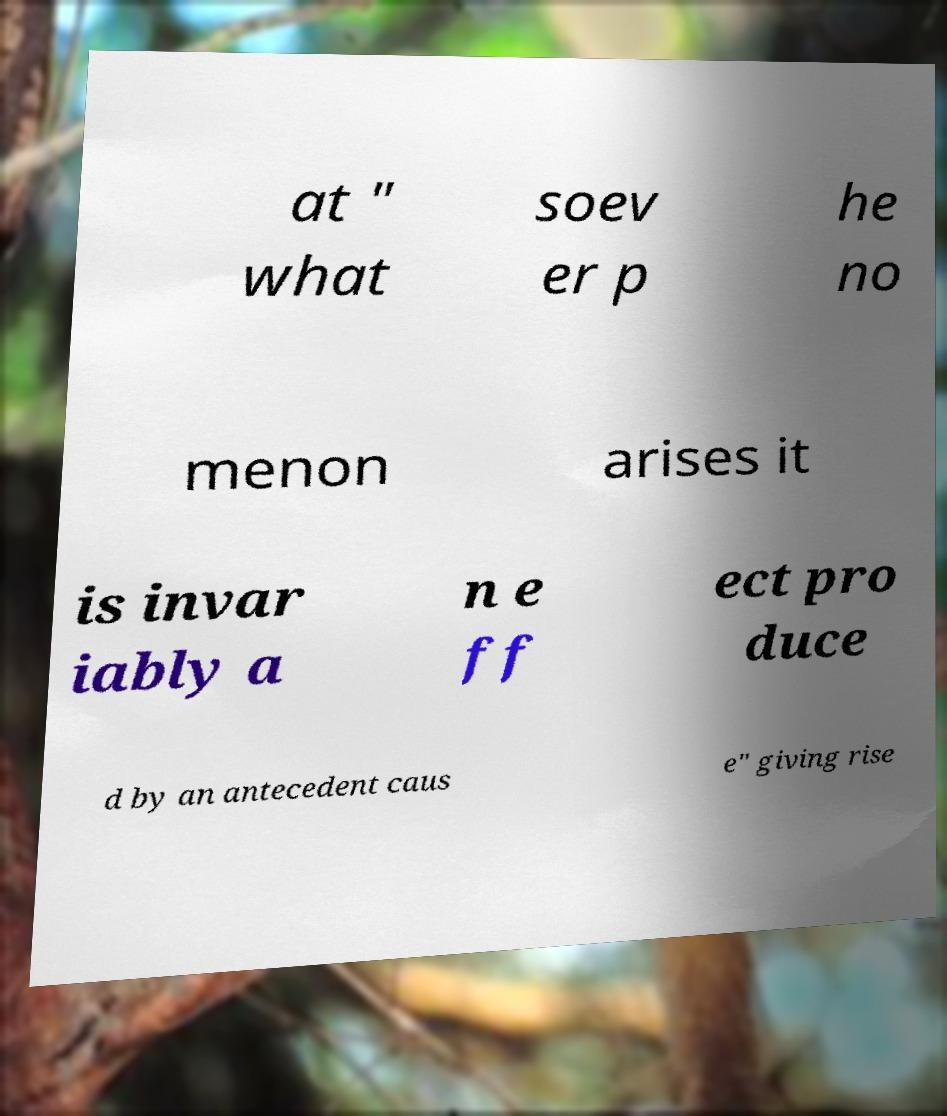Can you accurately transcribe the text from the provided image for me? at " what soev er p he no menon arises it is invar iably a n e ff ect pro duce d by an antecedent caus e" giving rise 